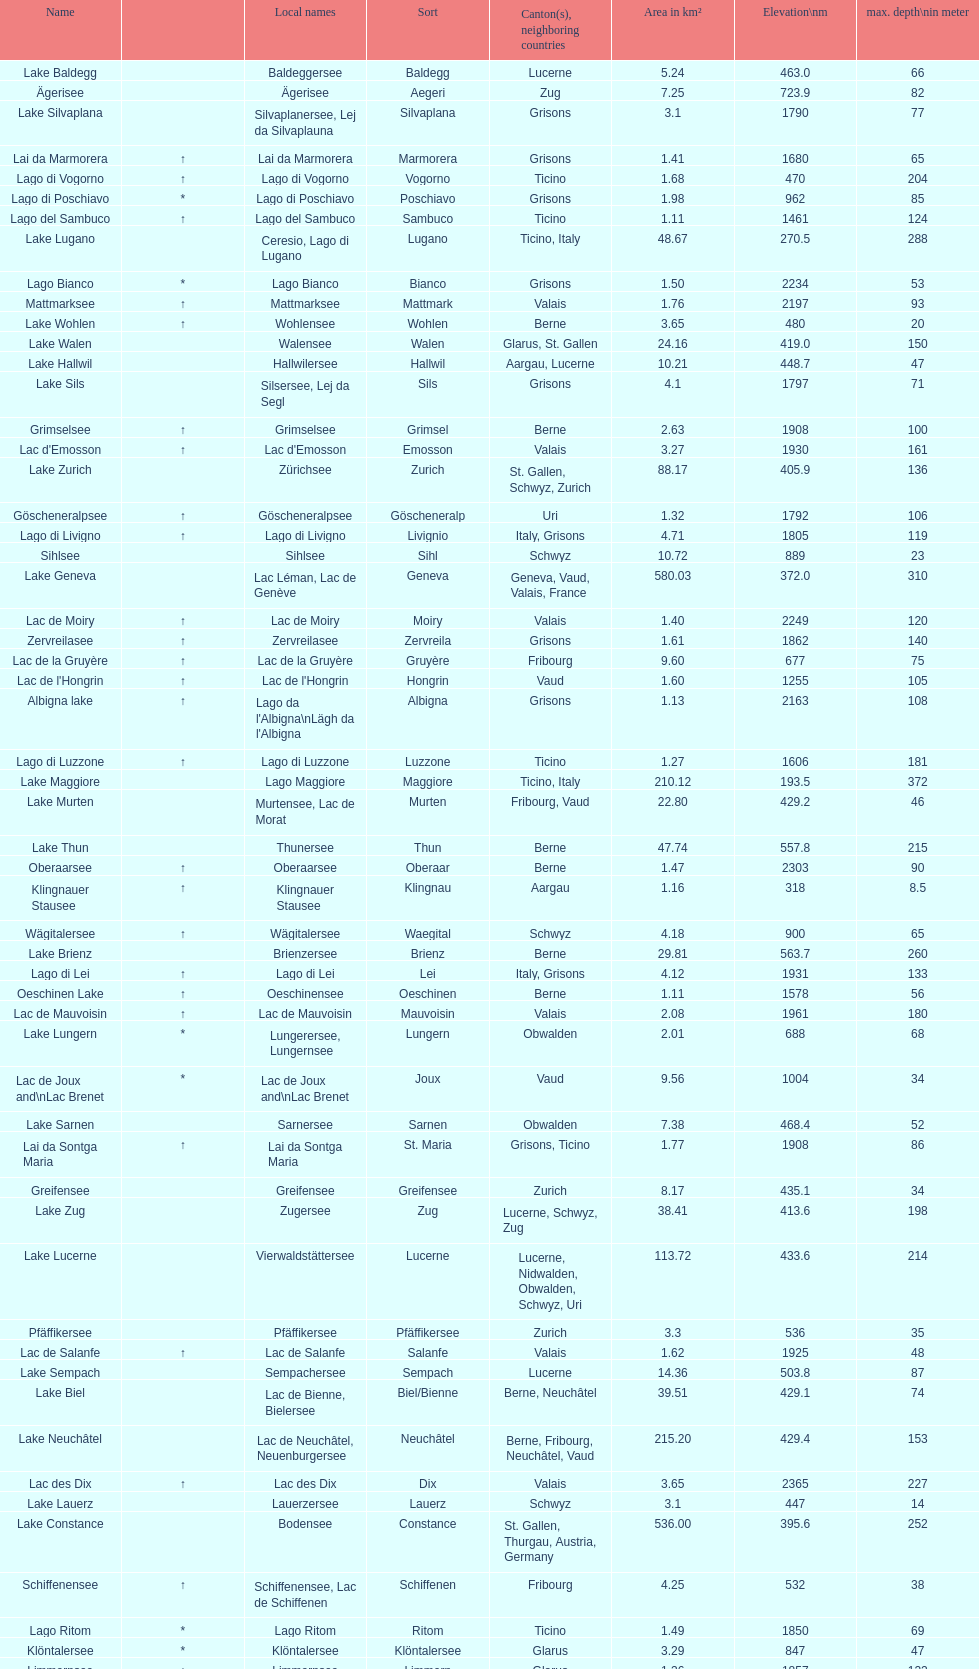What is the number of lakes that have an area less than 100 km squared? 51. 